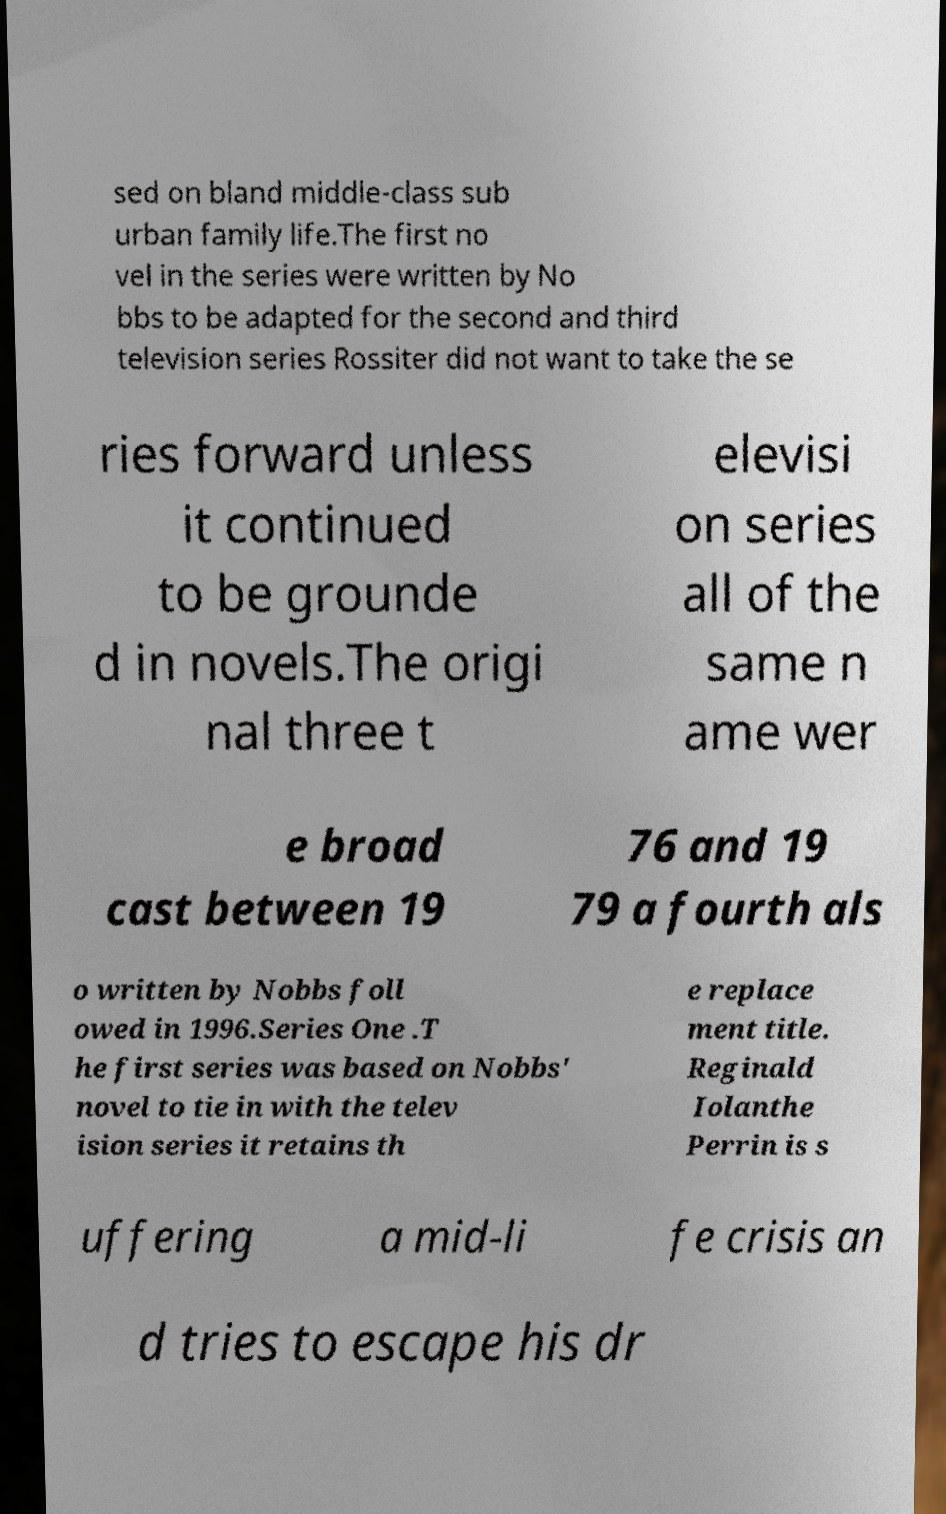Please identify and transcribe the text found in this image. sed on bland middle-class sub urban family life.The first no vel in the series were written by No bbs to be adapted for the second and third television series Rossiter did not want to take the se ries forward unless it continued to be grounde d in novels.The origi nal three t elevisi on series all of the same n ame wer e broad cast between 19 76 and 19 79 a fourth als o written by Nobbs foll owed in 1996.Series One .T he first series was based on Nobbs' novel to tie in with the telev ision series it retains th e replace ment title. Reginald Iolanthe Perrin is s uffering a mid-li fe crisis an d tries to escape his dr 